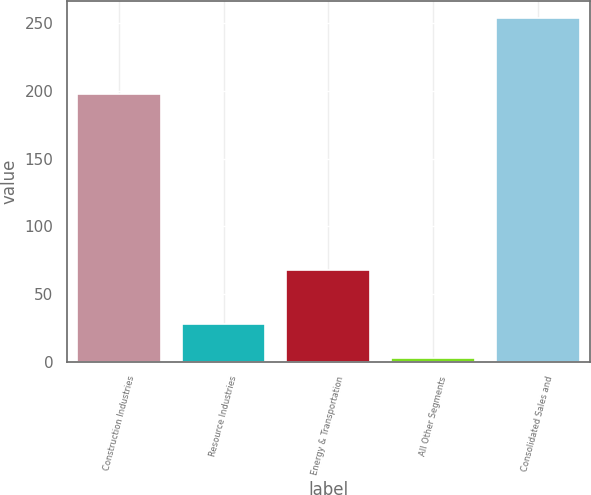Convert chart. <chart><loc_0><loc_0><loc_500><loc_500><bar_chart><fcel>Construction Industries<fcel>Resource Industries<fcel>Energy & Transportation<fcel>All Other Segments<fcel>Consolidated Sales and<nl><fcel>198<fcel>28.1<fcel>68<fcel>3<fcel>254<nl></chart> 